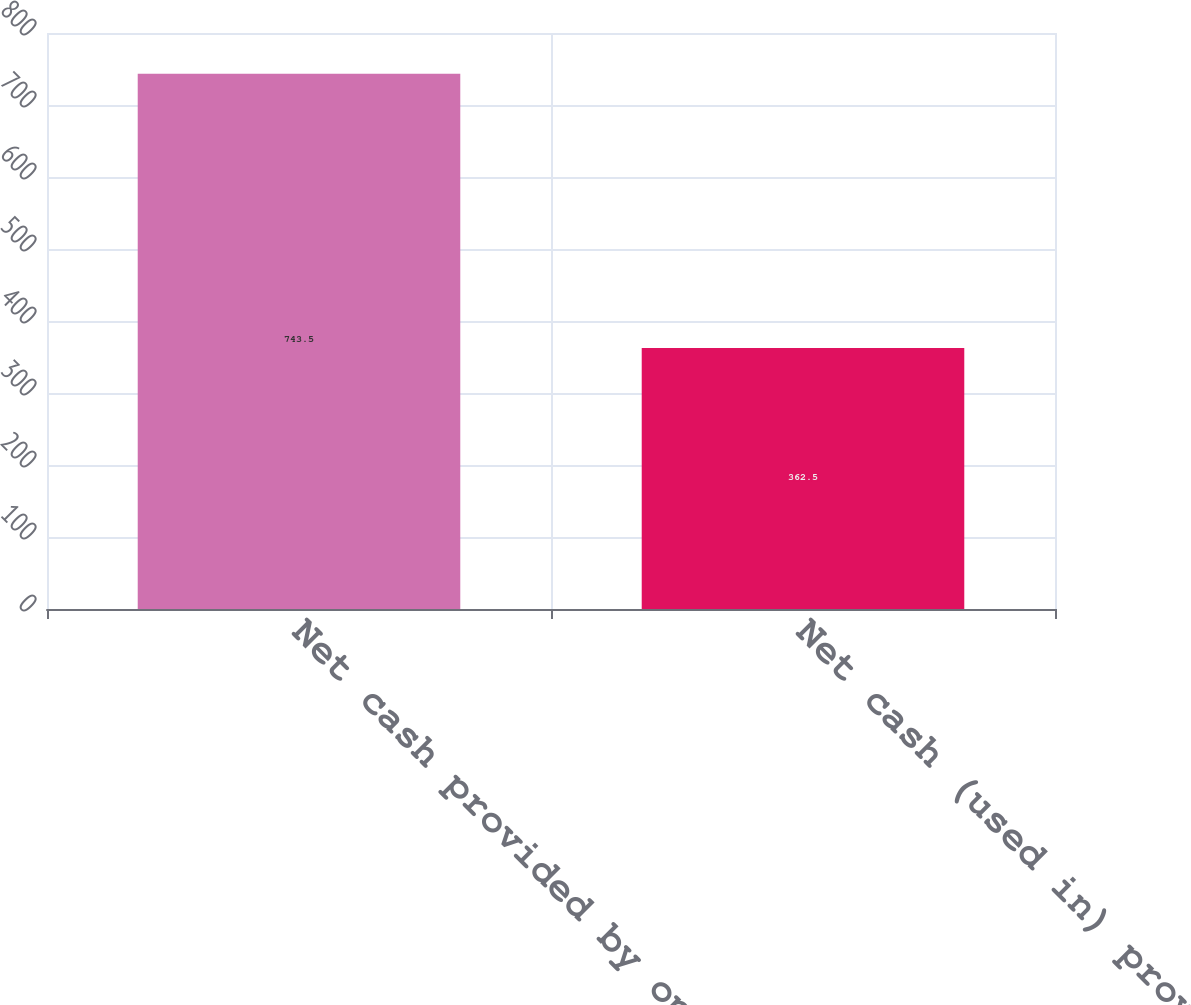Convert chart to OTSL. <chart><loc_0><loc_0><loc_500><loc_500><bar_chart><fcel>Net cash provided by operating<fcel>Net cash (used in) provided by<nl><fcel>743.5<fcel>362.5<nl></chart> 